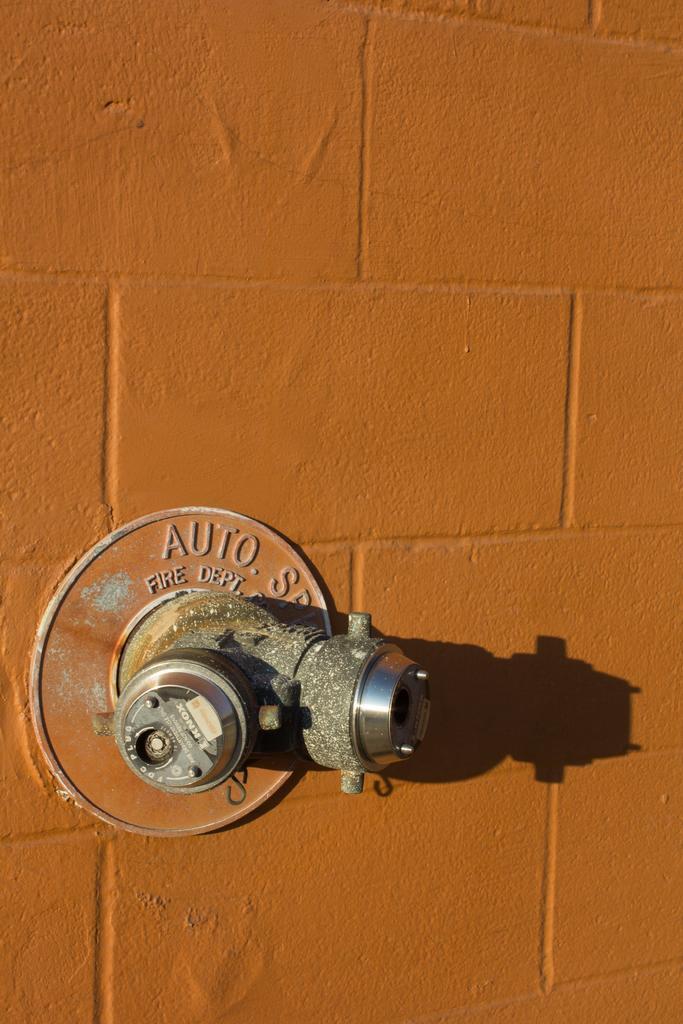In one or two sentences, can you explain what this image depicts? In this picture there is a brick wall painted in orange. On the left there is a tap. 